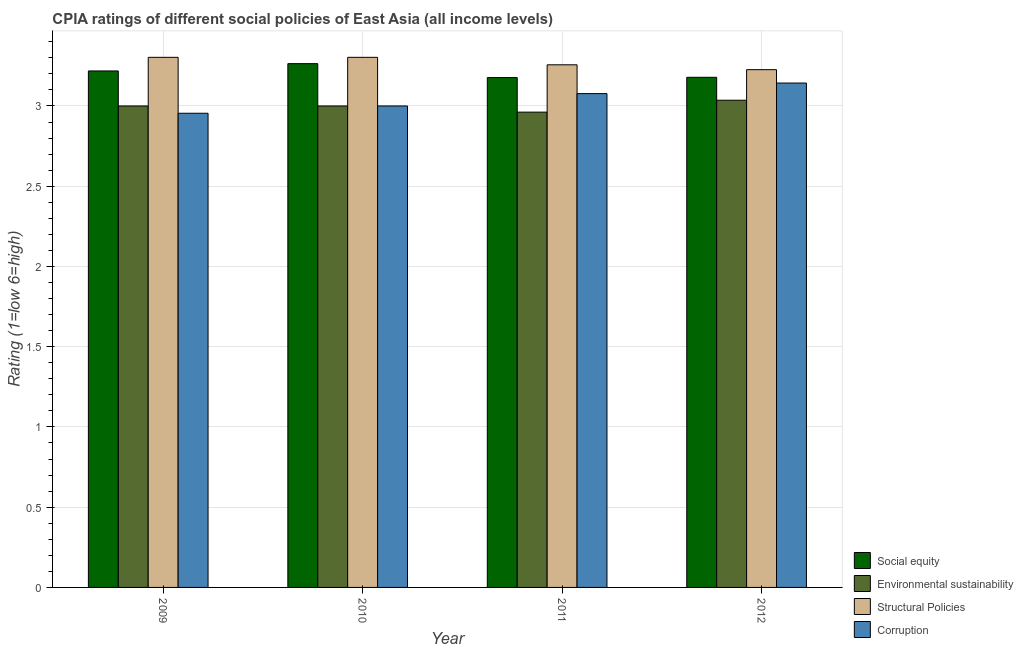Are the number of bars per tick equal to the number of legend labels?
Give a very brief answer. Yes. How many bars are there on the 4th tick from the left?
Offer a terse response. 4. How many bars are there on the 1st tick from the right?
Offer a terse response. 4. In how many cases, is the number of bars for a given year not equal to the number of legend labels?
Keep it short and to the point. 0. What is the cpia rating of corruption in 2010?
Give a very brief answer. 3. Across all years, what is the maximum cpia rating of social equity?
Provide a short and direct response. 3.26. Across all years, what is the minimum cpia rating of environmental sustainability?
Your response must be concise. 2.96. In which year was the cpia rating of social equity minimum?
Provide a short and direct response. 2011. What is the total cpia rating of environmental sustainability in the graph?
Ensure brevity in your answer.  12. What is the difference between the cpia rating of structural policies in 2010 and that in 2012?
Provide a succinct answer. 0.08. What is the difference between the cpia rating of corruption in 2012 and the cpia rating of social equity in 2011?
Keep it short and to the point. 0.07. What is the average cpia rating of structural policies per year?
Your answer should be very brief. 3.27. In the year 2009, what is the difference between the cpia rating of structural policies and cpia rating of social equity?
Your response must be concise. 0. In how many years, is the cpia rating of structural policies greater than 3.2?
Offer a terse response. 4. What is the ratio of the cpia rating of environmental sustainability in 2010 to that in 2011?
Offer a very short reply. 1.01. What is the difference between the highest and the second highest cpia rating of structural policies?
Your answer should be compact. 0. What is the difference between the highest and the lowest cpia rating of environmental sustainability?
Ensure brevity in your answer.  0.07. Is the sum of the cpia rating of social equity in 2011 and 2012 greater than the maximum cpia rating of structural policies across all years?
Keep it short and to the point. Yes. What does the 4th bar from the left in 2010 represents?
Your response must be concise. Corruption. What does the 2nd bar from the right in 2010 represents?
Offer a very short reply. Structural Policies. Are all the bars in the graph horizontal?
Provide a short and direct response. No. What is the difference between two consecutive major ticks on the Y-axis?
Your answer should be very brief. 0.5. Does the graph contain any zero values?
Make the answer very short. No. Where does the legend appear in the graph?
Your answer should be very brief. Bottom right. How are the legend labels stacked?
Offer a terse response. Vertical. What is the title of the graph?
Your answer should be compact. CPIA ratings of different social policies of East Asia (all income levels). Does "Offering training" appear as one of the legend labels in the graph?
Your response must be concise. No. What is the label or title of the X-axis?
Your answer should be very brief. Year. What is the Rating (1=low 6=high) in Social equity in 2009?
Keep it short and to the point. 3.22. What is the Rating (1=low 6=high) of Environmental sustainability in 2009?
Your response must be concise. 3. What is the Rating (1=low 6=high) in Structural Policies in 2009?
Your response must be concise. 3.3. What is the Rating (1=low 6=high) in Corruption in 2009?
Ensure brevity in your answer.  2.95. What is the Rating (1=low 6=high) in Social equity in 2010?
Ensure brevity in your answer.  3.26. What is the Rating (1=low 6=high) of Structural Policies in 2010?
Keep it short and to the point. 3.3. What is the Rating (1=low 6=high) in Social equity in 2011?
Offer a very short reply. 3.18. What is the Rating (1=low 6=high) in Environmental sustainability in 2011?
Your answer should be compact. 2.96. What is the Rating (1=low 6=high) in Structural Policies in 2011?
Ensure brevity in your answer.  3.26. What is the Rating (1=low 6=high) of Corruption in 2011?
Provide a short and direct response. 3.08. What is the Rating (1=low 6=high) of Social equity in 2012?
Provide a succinct answer. 3.18. What is the Rating (1=low 6=high) of Environmental sustainability in 2012?
Provide a short and direct response. 3.04. What is the Rating (1=low 6=high) in Structural Policies in 2012?
Give a very brief answer. 3.23. What is the Rating (1=low 6=high) in Corruption in 2012?
Provide a short and direct response. 3.14. Across all years, what is the maximum Rating (1=low 6=high) of Social equity?
Your answer should be very brief. 3.26. Across all years, what is the maximum Rating (1=low 6=high) of Environmental sustainability?
Offer a terse response. 3.04. Across all years, what is the maximum Rating (1=low 6=high) in Structural Policies?
Offer a very short reply. 3.3. Across all years, what is the maximum Rating (1=low 6=high) in Corruption?
Provide a succinct answer. 3.14. Across all years, what is the minimum Rating (1=low 6=high) of Social equity?
Give a very brief answer. 3.18. Across all years, what is the minimum Rating (1=low 6=high) of Environmental sustainability?
Provide a succinct answer. 2.96. Across all years, what is the minimum Rating (1=low 6=high) in Structural Policies?
Provide a short and direct response. 3.23. Across all years, what is the minimum Rating (1=low 6=high) of Corruption?
Make the answer very short. 2.95. What is the total Rating (1=low 6=high) in Social equity in the graph?
Offer a terse response. 12.84. What is the total Rating (1=low 6=high) in Environmental sustainability in the graph?
Your answer should be compact. 12. What is the total Rating (1=low 6=high) in Structural Policies in the graph?
Your answer should be compact. 13.09. What is the total Rating (1=low 6=high) in Corruption in the graph?
Keep it short and to the point. 12.17. What is the difference between the Rating (1=low 6=high) of Social equity in 2009 and that in 2010?
Your answer should be very brief. -0.05. What is the difference between the Rating (1=low 6=high) in Corruption in 2009 and that in 2010?
Keep it short and to the point. -0.05. What is the difference between the Rating (1=low 6=high) in Social equity in 2009 and that in 2011?
Offer a very short reply. 0.04. What is the difference between the Rating (1=low 6=high) in Environmental sustainability in 2009 and that in 2011?
Ensure brevity in your answer.  0.04. What is the difference between the Rating (1=low 6=high) of Structural Policies in 2009 and that in 2011?
Make the answer very short. 0.05. What is the difference between the Rating (1=low 6=high) of Corruption in 2009 and that in 2011?
Your answer should be very brief. -0.12. What is the difference between the Rating (1=low 6=high) in Social equity in 2009 and that in 2012?
Offer a very short reply. 0.04. What is the difference between the Rating (1=low 6=high) of Environmental sustainability in 2009 and that in 2012?
Offer a very short reply. -0.04. What is the difference between the Rating (1=low 6=high) in Structural Policies in 2009 and that in 2012?
Keep it short and to the point. 0.08. What is the difference between the Rating (1=low 6=high) of Corruption in 2009 and that in 2012?
Your answer should be very brief. -0.19. What is the difference between the Rating (1=low 6=high) in Social equity in 2010 and that in 2011?
Provide a short and direct response. 0.09. What is the difference between the Rating (1=low 6=high) of Environmental sustainability in 2010 and that in 2011?
Give a very brief answer. 0.04. What is the difference between the Rating (1=low 6=high) in Structural Policies in 2010 and that in 2011?
Provide a short and direct response. 0.05. What is the difference between the Rating (1=low 6=high) in Corruption in 2010 and that in 2011?
Ensure brevity in your answer.  -0.08. What is the difference between the Rating (1=low 6=high) of Social equity in 2010 and that in 2012?
Offer a very short reply. 0.09. What is the difference between the Rating (1=low 6=high) of Environmental sustainability in 2010 and that in 2012?
Ensure brevity in your answer.  -0.04. What is the difference between the Rating (1=low 6=high) of Structural Policies in 2010 and that in 2012?
Offer a very short reply. 0.08. What is the difference between the Rating (1=low 6=high) in Corruption in 2010 and that in 2012?
Provide a succinct answer. -0.14. What is the difference between the Rating (1=low 6=high) in Social equity in 2011 and that in 2012?
Provide a short and direct response. -0. What is the difference between the Rating (1=low 6=high) in Environmental sustainability in 2011 and that in 2012?
Provide a succinct answer. -0.07. What is the difference between the Rating (1=low 6=high) in Structural Policies in 2011 and that in 2012?
Your response must be concise. 0.03. What is the difference between the Rating (1=low 6=high) in Corruption in 2011 and that in 2012?
Ensure brevity in your answer.  -0.07. What is the difference between the Rating (1=low 6=high) of Social equity in 2009 and the Rating (1=low 6=high) of Environmental sustainability in 2010?
Provide a short and direct response. 0.22. What is the difference between the Rating (1=low 6=high) in Social equity in 2009 and the Rating (1=low 6=high) in Structural Policies in 2010?
Your answer should be compact. -0.08. What is the difference between the Rating (1=low 6=high) in Social equity in 2009 and the Rating (1=low 6=high) in Corruption in 2010?
Offer a terse response. 0.22. What is the difference between the Rating (1=low 6=high) of Environmental sustainability in 2009 and the Rating (1=low 6=high) of Structural Policies in 2010?
Your answer should be compact. -0.3. What is the difference between the Rating (1=low 6=high) of Environmental sustainability in 2009 and the Rating (1=low 6=high) of Corruption in 2010?
Make the answer very short. 0. What is the difference between the Rating (1=low 6=high) of Structural Policies in 2009 and the Rating (1=low 6=high) of Corruption in 2010?
Provide a short and direct response. 0.3. What is the difference between the Rating (1=low 6=high) in Social equity in 2009 and the Rating (1=low 6=high) in Environmental sustainability in 2011?
Your answer should be very brief. 0.26. What is the difference between the Rating (1=low 6=high) of Social equity in 2009 and the Rating (1=low 6=high) of Structural Policies in 2011?
Keep it short and to the point. -0.04. What is the difference between the Rating (1=low 6=high) in Social equity in 2009 and the Rating (1=low 6=high) in Corruption in 2011?
Provide a succinct answer. 0.14. What is the difference between the Rating (1=low 6=high) of Environmental sustainability in 2009 and the Rating (1=low 6=high) of Structural Policies in 2011?
Your answer should be very brief. -0.26. What is the difference between the Rating (1=low 6=high) of Environmental sustainability in 2009 and the Rating (1=low 6=high) of Corruption in 2011?
Make the answer very short. -0.08. What is the difference between the Rating (1=low 6=high) of Structural Policies in 2009 and the Rating (1=low 6=high) of Corruption in 2011?
Ensure brevity in your answer.  0.23. What is the difference between the Rating (1=low 6=high) of Social equity in 2009 and the Rating (1=low 6=high) of Environmental sustainability in 2012?
Your response must be concise. 0.18. What is the difference between the Rating (1=low 6=high) of Social equity in 2009 and the Rating (1=low 6=high) of Structural Policies in 2012?
Provide a succinct answer. -0.01. What is the difference between the Rating (1=low 6=high) in Social equity in 2009 and the Rating (1=low 6=high) in Corruption in 2012?
Ensure brevity in your answer.  0.08. What is the difference between the Rating (1=low 6=high) in Environmental sustainability in 2009 and the Rating (1=low 6=high) in Structural Policies in 2012?
Keep it short and to the point. -0.23. What is the difference between the Rating (1=low 6=high) of Environmental sustainability in 2009 and the Rating (1=low 6=high) of Corruption in 2012?
Provide a succinct answer. -0.14. What is the difference between the Rating (1=low 6=high) in Structural Policies in 2009 and the Rating (1=low 6=high) in Corruption in 2012?
Offer a very short reply. 0.16. What is the difference between the Rating (1=low 6=high) of Social equity in 2010 and the Rating (1=low 6=high) of Environmental sustainability in 2011?
Give a very brief answer. 0.3. What is the difference between the Rating (1=low 6=high) of Social equity in 2010 and the Rating (1=low 6=high) of Structural Policies in 2011?
Offer a very short reply. 0.01. What is the difference between the Rating (1=low 6=high) in Social equity in 2010 and the Rating (1=low 6=high) in Corruption in 2011?
Your answer should be compact. 0.19. What is the difference between the Rating (1=low 6=high) of Environmental sustainability in 2010 and the Rating (1=low 6=high) of Structural Policies in 2011?
Give a very brief answer. -0.26. What is the difference between the Rating (1=low 6=high) in Environmental sustainability in 2010 and the Rating (1=low 6=high) in Corruption in 2011?
Give a very brief answer. -0.08. What is the difference between the Rating (1=low 6=high) in Structural Policies in 2010 and the Rating (1=low 6=high) in Corruption in 2011?
Offer a very short reply. 0.23. What is the difference between the Rating (1=low 6=high) of Social equity in 2010 and the Rating (1=low 6=high) of Environmental sustainability in 2012?
Provide a succinct answer. 0.23. What is the difference between the Rating (1=low 6=high) in Social equity in 2010 and the Rating (1=low 6=high) in Structural Policies in 2012?
Offer a very short reply. 0.04. What is the difference between the Rating (1=low 6=high) in Social equity in 2010 and the Rating (1=low 6=high) in Corruption in 2012?
Your answer should be compact. 0.12. What is the difference between the Rating (1=low 6=high) in Environmental sustainability in 2010 and the Rating (1=low 6=high) in Structural Policies in 2012?
Your answer should be very brief. -0.23. What is the difference between the Rating (1=low 6=high) in Environmental sustainability in 2010 and the Rating (1=low 6=high) in Corruption in 2012?
Make the answer very short. -0.14. What is the difference between the Rating (1=low 6=high) in Structural Policies in 2010 and the Rating (1=low 6=high) in Corruption in 2012?
Your answer should be very brief. 0.16. What is the difference between the Rating (1=low 6=high) in Social equity in 2011 and the Rating (1=low 6=high) in Environmental sustainability in 2012?
Your answer should be very brief. 0.14. What is the difference between the Rating (1=low 6=high) in Social equity in 2011 and the Rating (1=low 6=high) in Structural Policies in 2012?
Offer a terse response. -0.05. What is the difference between the Rating (1=low 6=high) in Social equity in 2011 and the Rating (1=low 6=high) in Corruption in 2012?
Make the answer very short. 0.03. What is the difference between the Rating (1=low 6=high) of Environmental sustainability in 2011 and the Rating (1=low 6=high) of Structural Policies in 2012?
Keep it short and to the point. -0.26. What is the difference between the Rating (1=low 6=high) in Environmental sustainability in 2011 and the Rating (1=low 6=high) in Corruption in 2012?
Your answer should be compact. -0.18. What is the difference between the Rating (1=low 6=high) of Structural Policies in 2011 and the Rating (1=low 6=high) of Corruption in 2012?
Provide a short and direct response. 0.11. What is the average Rating (1=low 6=high) in Social equity per year?
Give a very brief answer. 3.21. What is the average Rating (1=low 6=high) of Environmental sustainability per year?
Make the answer very short. 3. What is the average Rating (1=low 6=high) of Structural Policies per year?
Your response must be concise. 3.27. What is the average Rating (1=low 6=high) of Corruption per year?
Your answer should be very brief. 3.04. In the year 2009, what is the difference between the Rating (1=low 6=high) in Social equity and Rating (1=low 6=high) in Environmental sustainability?
Offer a terse response. 0.22. In the year 2009, what is the difference between the Rating (1=low 6=high) of Social equity and Rating (1=low 6=high) of Structural Policies?
Ensure brevity in your answer.  -0.08. In the year 2009, what is the difference between the Rating (1=low 6=high) of Social equity and Rating (1=low 6=high) of Corruption?
Your answer should be very brief. 0.26. In the year 2009, what is the difference between the Rating (1=low 6=high) in Environmental sustainability and Rating (1=low 6=high) in Structural Policies?
Offer a very short reply. -0.3. In the year 2009, what is the difference between the Rating (1=low 6=high) in Environmental sustainability and Rating (1=low 6=high) in Corruption?
Provide a succinct answer. 0.05. In the year 2009, what is the difference between the Rating (1=low 6=high) in Structural Policies and Rating (1=low 6=high) in Corruption?
Provide a succinct answer. 0.35. In the year 2010, what is the difference between the Rating (1=low 6=high) of Social equity and Rating (1=low 6=high) of Environmental sustainability?
Keep it short and to the point. 0.26. In the year 2010, what is the difference between the Rating (1=low 6=high) of Social equity and Rating (1=low 6=high) of Structural Policies?
Give a very brief answer. -0.04. In the year 2010, what is the difference between the Rating (1=low 6=high) of Social equity and Rating (1=low 6=high) of Corruption?
Ensure brevity in your answer.  0.26. In the year 2010, what is the difference between the Rating (1=low 6=high) in Environmental sustainability and Rating (1=low 6=high) in Structural Policies?
Make the answer very short. -0.3. In the year 2010, what is the difference between the Rating (1=low 6=high) of Structural Policies and Rating (1=low 6=high) of Corruption?
Offer a terse response. 0.3. In the year 2011, what is the difference between the Rating (1=low 6=high) of Social equity and Rating (1=low 6=high) of Environmental sustainability?
Provide a succinct answer. 0.22. In the year 2011, what is the difference between the Rating (1=low 6=high) of Social equity and Rating (1=low 6=high) of Structural Policies?
Give a very brief answer. -0.08. In the year 2011, what is the difference between the Rating (1=low 6=high) in Environmental sustainability and Rating (1=low 6=high) in Structural Policies?
Offer a terse response. -0.29. In the year 2011, what is the difference between the Rating (1=low 6=high) in Environmental sustainability and Rating (1=low 6=high) in Corruption?
Offer a terse response. -0.12. In the year 2011, what is the difference between the Rating (1=low 6=high) in Structural Policies and Rating (1=low 6=high) in Corruption?
Keep it short and to the point. 0.18. In the year 2012, what is the difference between the Rating (1=low 6=high) in Social equity and Rating (1=low 6=high) in Environmental sustainability?
Your response must be concise. 0.14. In the year 2012, what is the difference between the Rating (1=low 6=high) in Social equity and Rating (1=low 6=high) in Structural Policies?
Make the answer very short. -0.05. In the year 2012, what is the difference between the Rating (1=low 6=high) of Social equity and Rating (1=low 6=high) of Corruption?
Make the answer very short. 0.04. In the year 2012, what is the difference between the Rating (1=low 6=high) of Environmental sustainability and Rating (1=low 6=high) of Structural Policies?
Keep it short and to the point. -0.19. In the year 2012, what is the difference between the Rating (1=low 6=high) in Environmental sustainability and Rating (1=low 6=high) in Corruption?
Provide a short and direct response. -0.11. In the year 2012, what is the difference between the Rating (1=low 6=high) of Structural Policies and Rating (1=low 6=high) of Corruption?
Your answer should be very brief. 0.08. What is the ratio of the Rating (1=low 6=high) of Social equity in 2009 to that in 2010?
Keep it short and to the point. 0.99. What is the ratio of the Rating (1=low 6=high) in Structural Policies in 2009 to that in 2010?
Provide a succinct answer. 1. What is the ratio of the Rating (1=low 6=high) in Environmental sustainability in 2009 to that in 2011?
Provide a short and direct response. 1.01. What is the ratio of the Rating (1=low 6=high) in Structural Policies in 2009 to that in 2011?
Your response must be concise. 1.01. What is the ratio of the Rating (1=low 6=high) of Corruption in 2009 to that in 2011?
Your answer should be very brief. 0.96. What is the ratio of the Rating (1=low 6=high) in Social equity in 2009 to that in 2012?
Give a very brief answer. 1.01. What is the ratio of the Rating (1=low 6=high) of Structural Policies in 2009 to that in 2012?
Offer a very short reply. 1.02. What is the ratio of the Rating (1=low 6=high) of Corruption in 2009 to that in 2012?
Give a very brief answer. 0.94. What is the ratio of the Rating (1=low 6=high) of Social equity in 2010 to that in 2011?
Provide a short and direct response. 1.03. What is the ratio of the Rating (1=low 6=high) of Structural Policies in 2010 to that in 2011?
Ensure brevity in your answer.  1.01. What is the ratio of the Rating (1=low 6=high) in Social equity in 2010 to that in 2012?
Give a very brief answer. 1.03. What is the ratio of the Rating (1=low 6=high) in Environmental sustainability in 2010 to that in 2012?
Give a very brief answer. 0.99. What is the ratio of the Rating (1=low 6=high) of Structural Policies in 2010 to that in 2012?
Provide a succinct answer. 1.02. What is the ratio of the Rating (1=low 6=high) in Corruption in 2010 to that in 2012?
Offer a terse response. 0.95. What is the ratio of the Rating (1=low 6=high) in Environmental sustainability in 2011 to that in 2012?
Provide a succinct answer. 0.98. What is the ratio of the Rating (1=low 6=high) of Structural Policies in 2011 to that in 2012?
Give a very brief answer. 1.01. What is the difference between the highest and the second highest Rating (1=low 6=high) in Social equity?
Ensure brevity in your answer.  0.05. What is the difference between the highest and the second highest Rating (1=low 6=high) in Environmental sustainability?
Your answer should be very brief. 0.04. What is the difference between the highest and the second highest Rating (1=low 6=high) in Structural Policies?
Keep it short and to the point. 0. What is the difference between the highest and the second highest Rating (1=low 6=high) of Corruption?
Ensure brevity in your answer.  0.07. What is the difference between the highest and the lowest Rating (1=low 6=high) of Social equity?
Offer a terse response. 0.09. What is the difference between the highest and the lowest Rating (1=low 6=high) in Environmental sustainability?
Provide a succinct answer. 0.07. What is the difference between the highest and the lowest Rating (1=low 6=high) of Structural Policies?
Your answer should be compact. 0.08. What is the difference between the highest and the lowest Rating (1=low 6=high) of Corruption?
Your answer should be very brief. 0.19. 